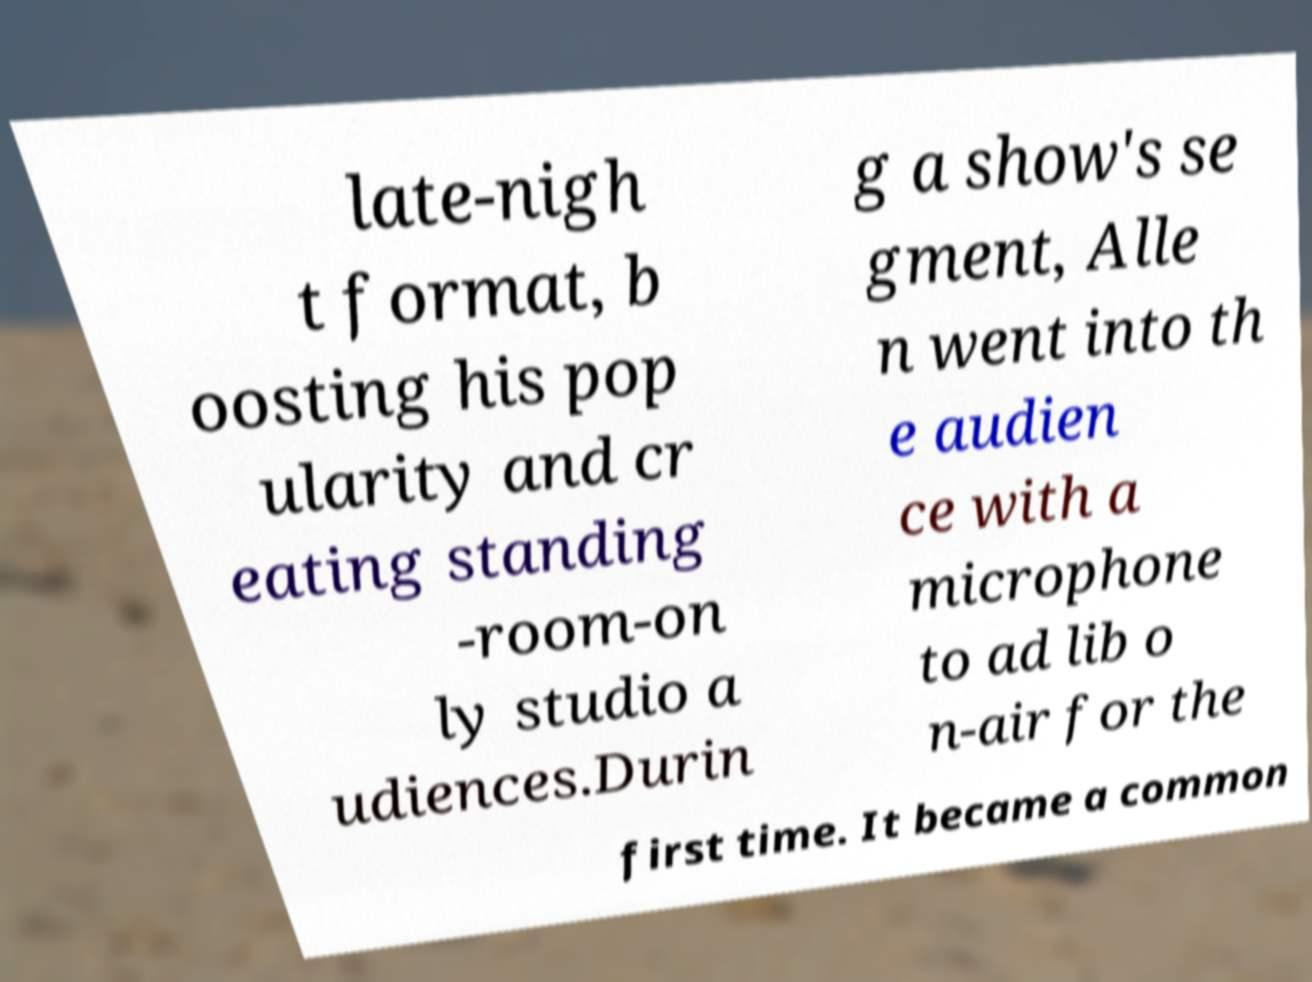Please read and relay the text visible in this image. What does it say? late-nigh t format, b oosting his pop ularity and cr eating standing -room-on ly studio a udiences.Durin g a show's se gment, Alle n went into th e audien ce with a microphone to ad lib o n-air for the first time. It became a common 